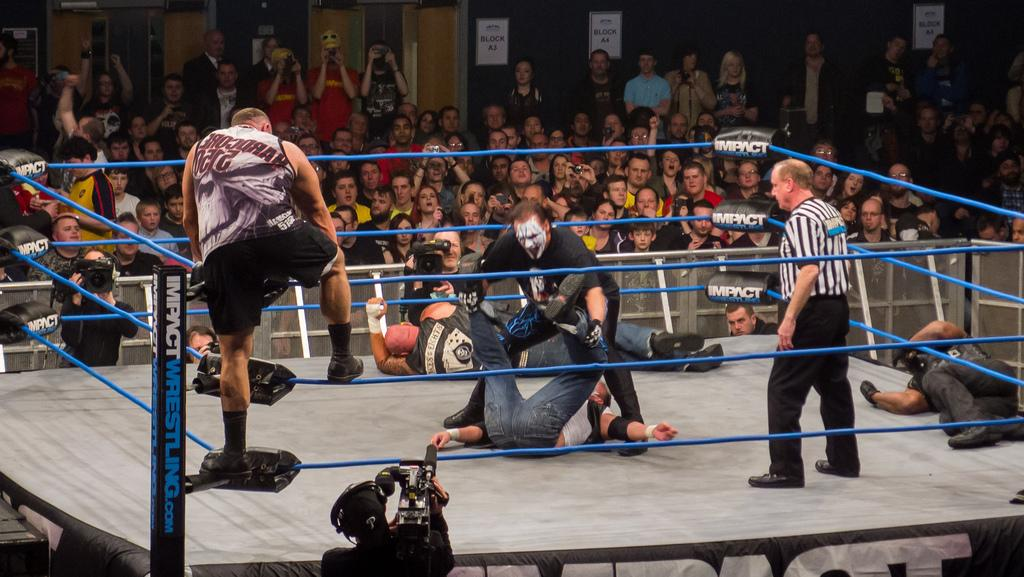What are the main subjects in the center of the image? There are persons wrestling in the center of the image. Where is the referee located in the image? The referee is on the right side of the image. What can be seen in the background of the image? There is a crowd visible in the background, as well as a wall. What type of wound can be seen on the instrument in the image? There is no instrument or wound present in the image; it features persons wrestling and a referee. 